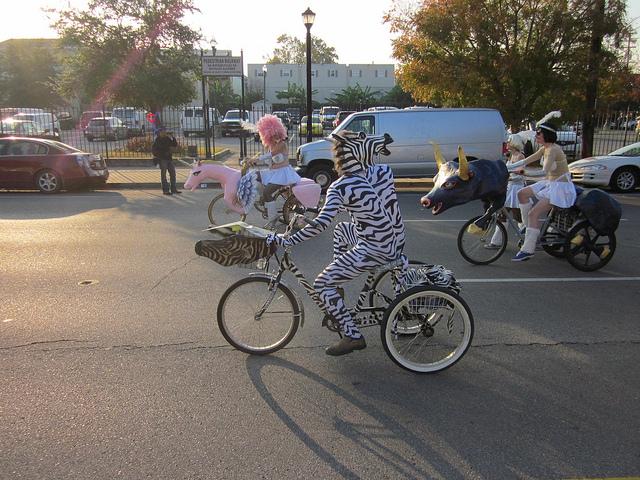What form of transportation is shown?
Answer briefly. Bike. Are these people riding in a park?
Concise answer only. No. What animal is the man on the bike dressed as?
Quick response, please. Zebra. What is parked outside of the buildings?
Keep it brief. Cars. Could this be Mardi Gras?
Quick response, please. Yes. Do you see a helmet?
Concise answer only. No. Are there any people?
Give a very brief answer. Yes. 